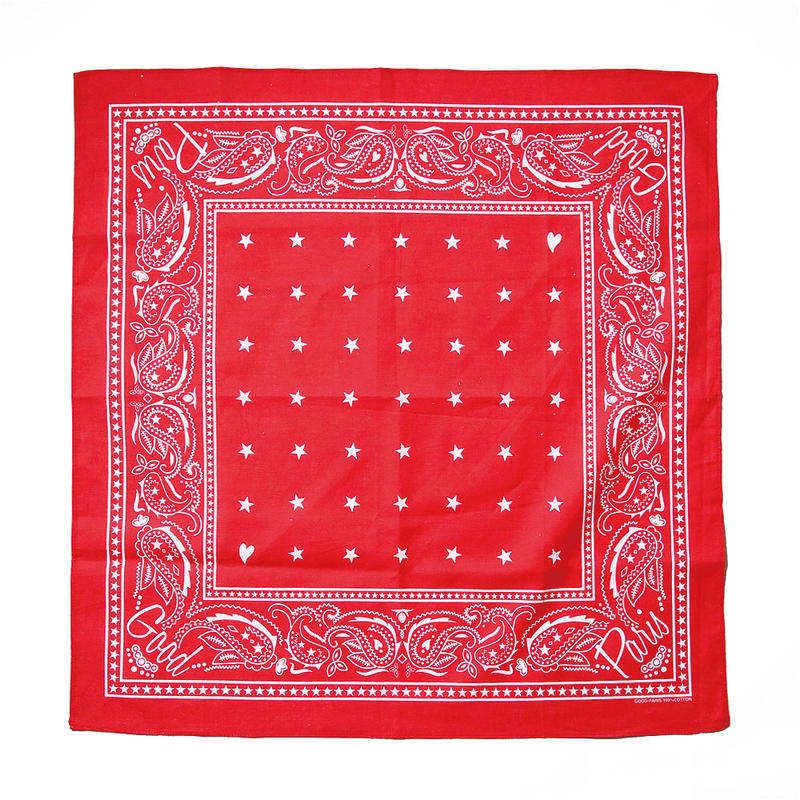Can you describe the patterns found on this bandana? The bandana showcases classic paisley patterns along its borders, rich in swirling teardrop shapes typically seen in traditional designs. Additionally, there are smaller star patterns scattered within the inner square, adding a touch of whimsy and contrast to the intricate border. What meaning or cultural significance might these patterns have? Paisley patterns originated from Persia and have been associated with wealth and elegance. The design often symbolizes life and eternity due to its intricate, never-ending swirls. Stars typically represent guidance or ambition, adding a layer of aspiration or direction. Together, these motifs blend to provide a rich tapestry of cultural connotations, blending heritage and hope. Create a short story incorporating the cultural significance of these patterns. In a small Persian village, a young girl named Leila cherished a bandana adorned with paisley and stars. Her grandmother had woven the fabric, imbuing each swirl with tales of their ancestors and each star with dreams of future generations. Wrapped around her head, the bandana became more than an accessory; it was a symbol of her lineage and her hopes. As Leila traveled to distant lands, she carried the essence of her heritage, with the intricate paisleys guarding her tales and the stars guiding her path. 